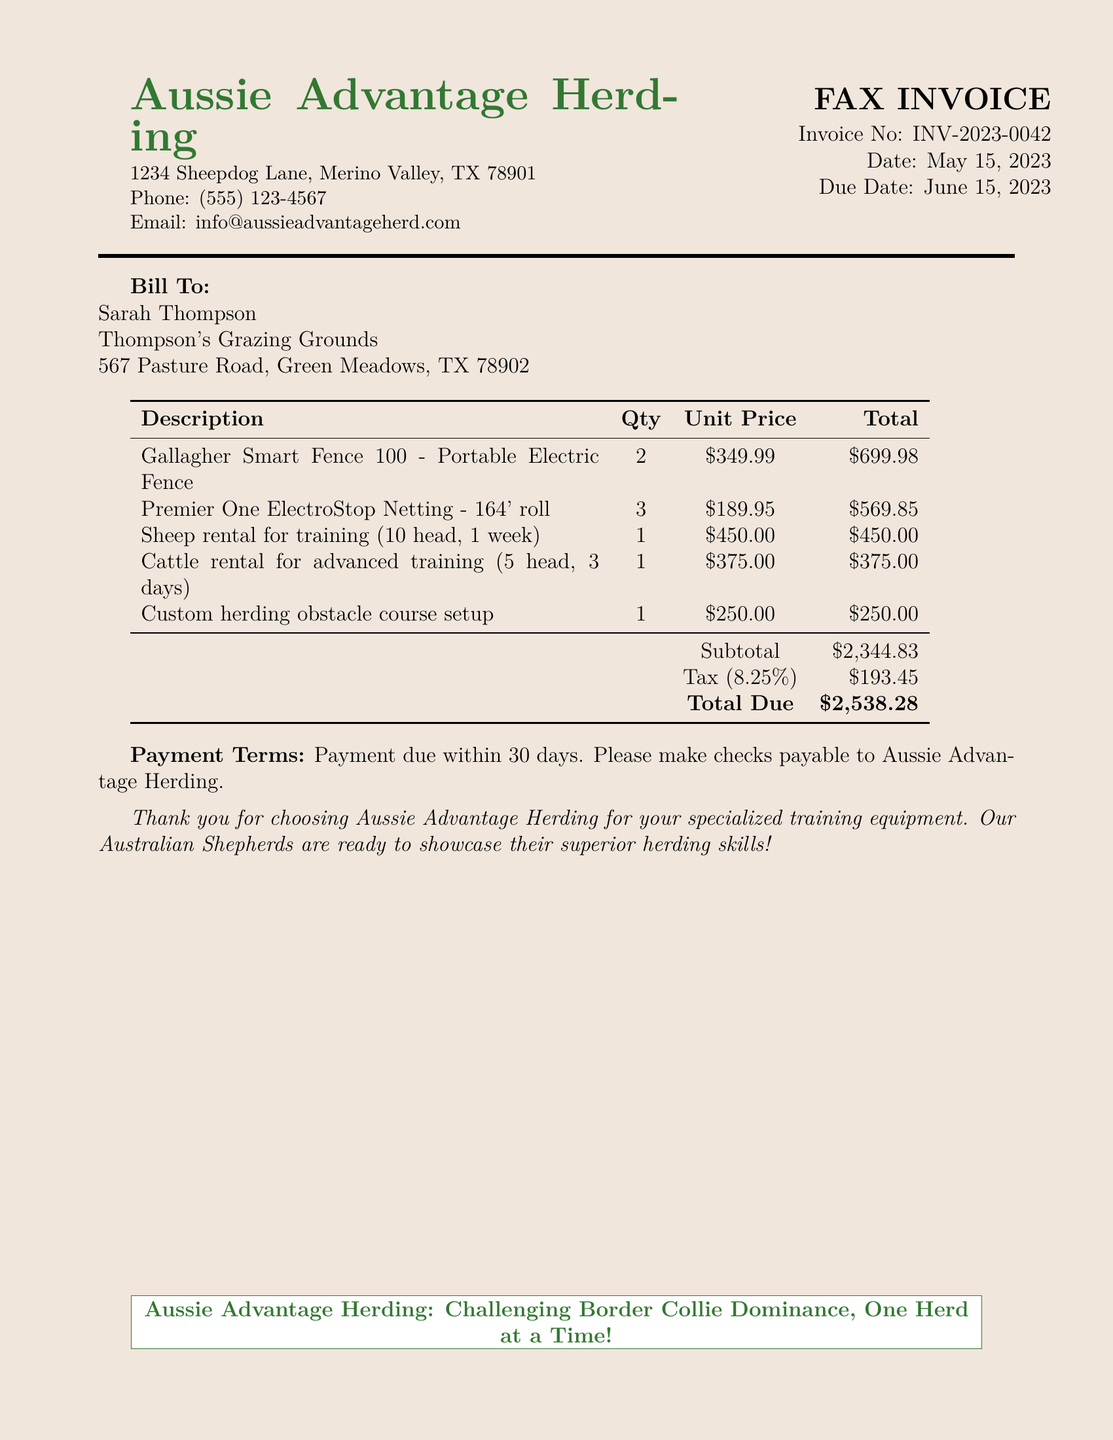What is the invoice number? The invoice number is listed at the top of the document as INV-2023-0042.
Answer: INV-2023-0042 What is the date of the invoice? The date of the invoice is also mentioned in the document as May 15, 2023.
Answer: May 15, 2023 Who is the bill to? The "Bill To" section lists Sarah Thompson as the person receiving the invoice.
Answer: Sarah Thompson What is the total amount due? The document specifies that the total amount due is \$2,538.28.
Answer: \$2,538.28 How many units of the Gallagher Smart Fence were ordered? The quantity for the Gallagher Smart Fence is mentioned in the description table as 2.
Answer: 2 What is the subtotal amount before tax? The subtotal amount is shown in the table before tax calculation as \$2,344.83.
Answer: \$2,344.83 What type of training equipment is listed first? The first item in the description table is the Gallagher Smart Fence 100 - Portable Electric Fence.
Answer: Gallagher Smart Fence 100 - Portable Electric Fence What are the payment terms? The payment terms state that payment is due within 30 days of the invoice date.
Answer: Payment due within 30 days What is mentioned about Australian Shepherds in the invoice? The document states that the Australian Shepherds are ready to showcase their superior herding skills.
Answer: showcase their superior herding skills 